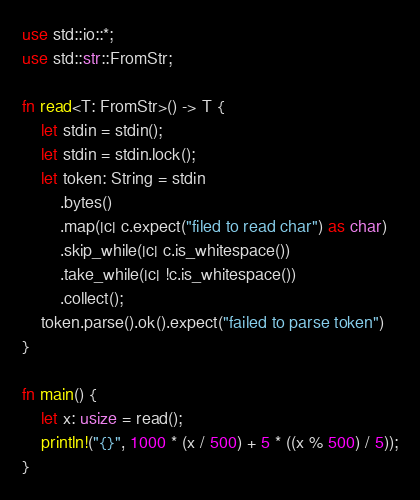<code> <loc_0><loc_0><loc_500><loc_500><_Rust_>use std::io::*;
use std::str::FromStr;

fn read<T: FromStr>() -> T {
    let stdin = stdin();
    let stdin = stdin.lock();
    let token: String = stdin
        .bytes()
        .map(|c| c.expect("filed to read char") as char)
        .skip_while(|c| c.is_whitespace())
        .take_while(|c| !c.is_whitespace())
        .collect();
    token.parse().ok().expect("failed to parse token")
}

fn main() {
    let x: usize = read();
    println!("{}", 1000 * (x / 500) + 5 * ((x % 500) / 5));
}
</code> 